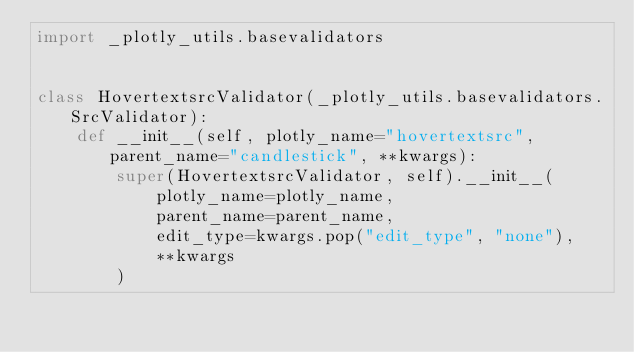Convert code to text. <code><loc_0><loc_0><loc_500><loc_500><_Python_>import _plotly_utils.basevalidators


class HovertextsrcValidator(_plotly_utils.basevalidators.SrcValidator):
    def __init__(self, plotly_name="hovertextsrc", parent_name="candlestick", **kwargs):
        super(HovertextsrcValidator, self).__init__(
            plotly_name=plotly_name,
            parent_name=parent_name,
            edit_type=kwargs.pop("edit_type", "none"),
            **kwargs
        )
</code> 